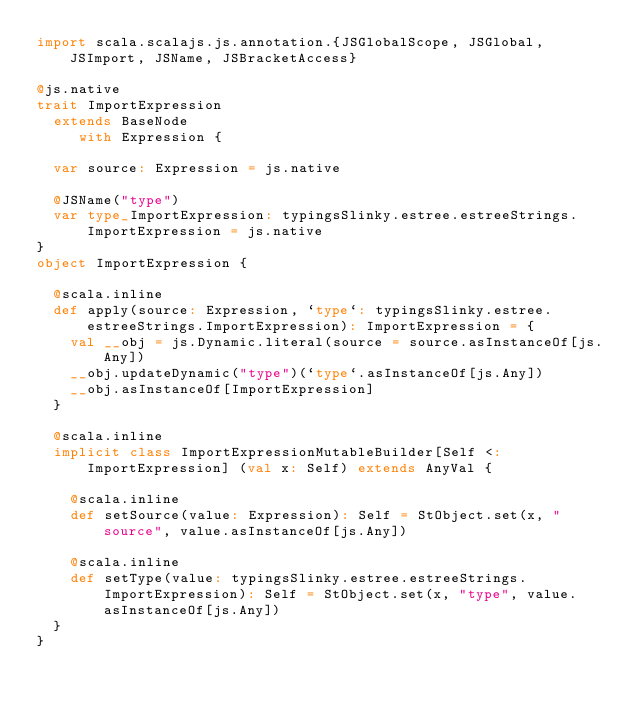<code> <loc_0><loc_0><loc_500><loc_500><_Scala_>import scala.scalajs.js.annotation.{JSGlobalScope, JSGlobal, JSImport, JSName, JSBracketAccess}

@js.native
trait ImportExpression
  extends BaseNode
     with Expression {
  
  var source: Expression = js.native
  
  @JSName("type")
  var type_ImportExpression: typingsSlinky.estree.estreeStrings.ImportExpression = js.native
}
object ImportExpression {
  
  @scala.inline
  def apply(source: Expression, `type`: typingsSlinky.estree.estreeStrings.ImportExpression): ImportExpression = {
    val __obj = js.Dynamic.literal(source = source.asInstanceOf[js.Any])
    __obj.updateDynamic("type")(`type`.asInstanceOf[js.Any])
    __obj.asInstanceOf[ImportExpression]
  }
  
  @scala.inline
  implicit class ImportExpressionMutableBuilder[Self <: ImportExpression] (val x: Self) extends AnyVal {
    
    @scala.inline
    def setSource(value: Expression): Self = StObject.set(x, "source", value.asInstanceOf[js.Any])
    
    @scala.inline
    def setType(value: typingsSlinky.estree.estreeStrings.ImportExpression): Self = StObject.set(x, "type", value.asInstanceOf[js.Any])
  }
}
</code> 